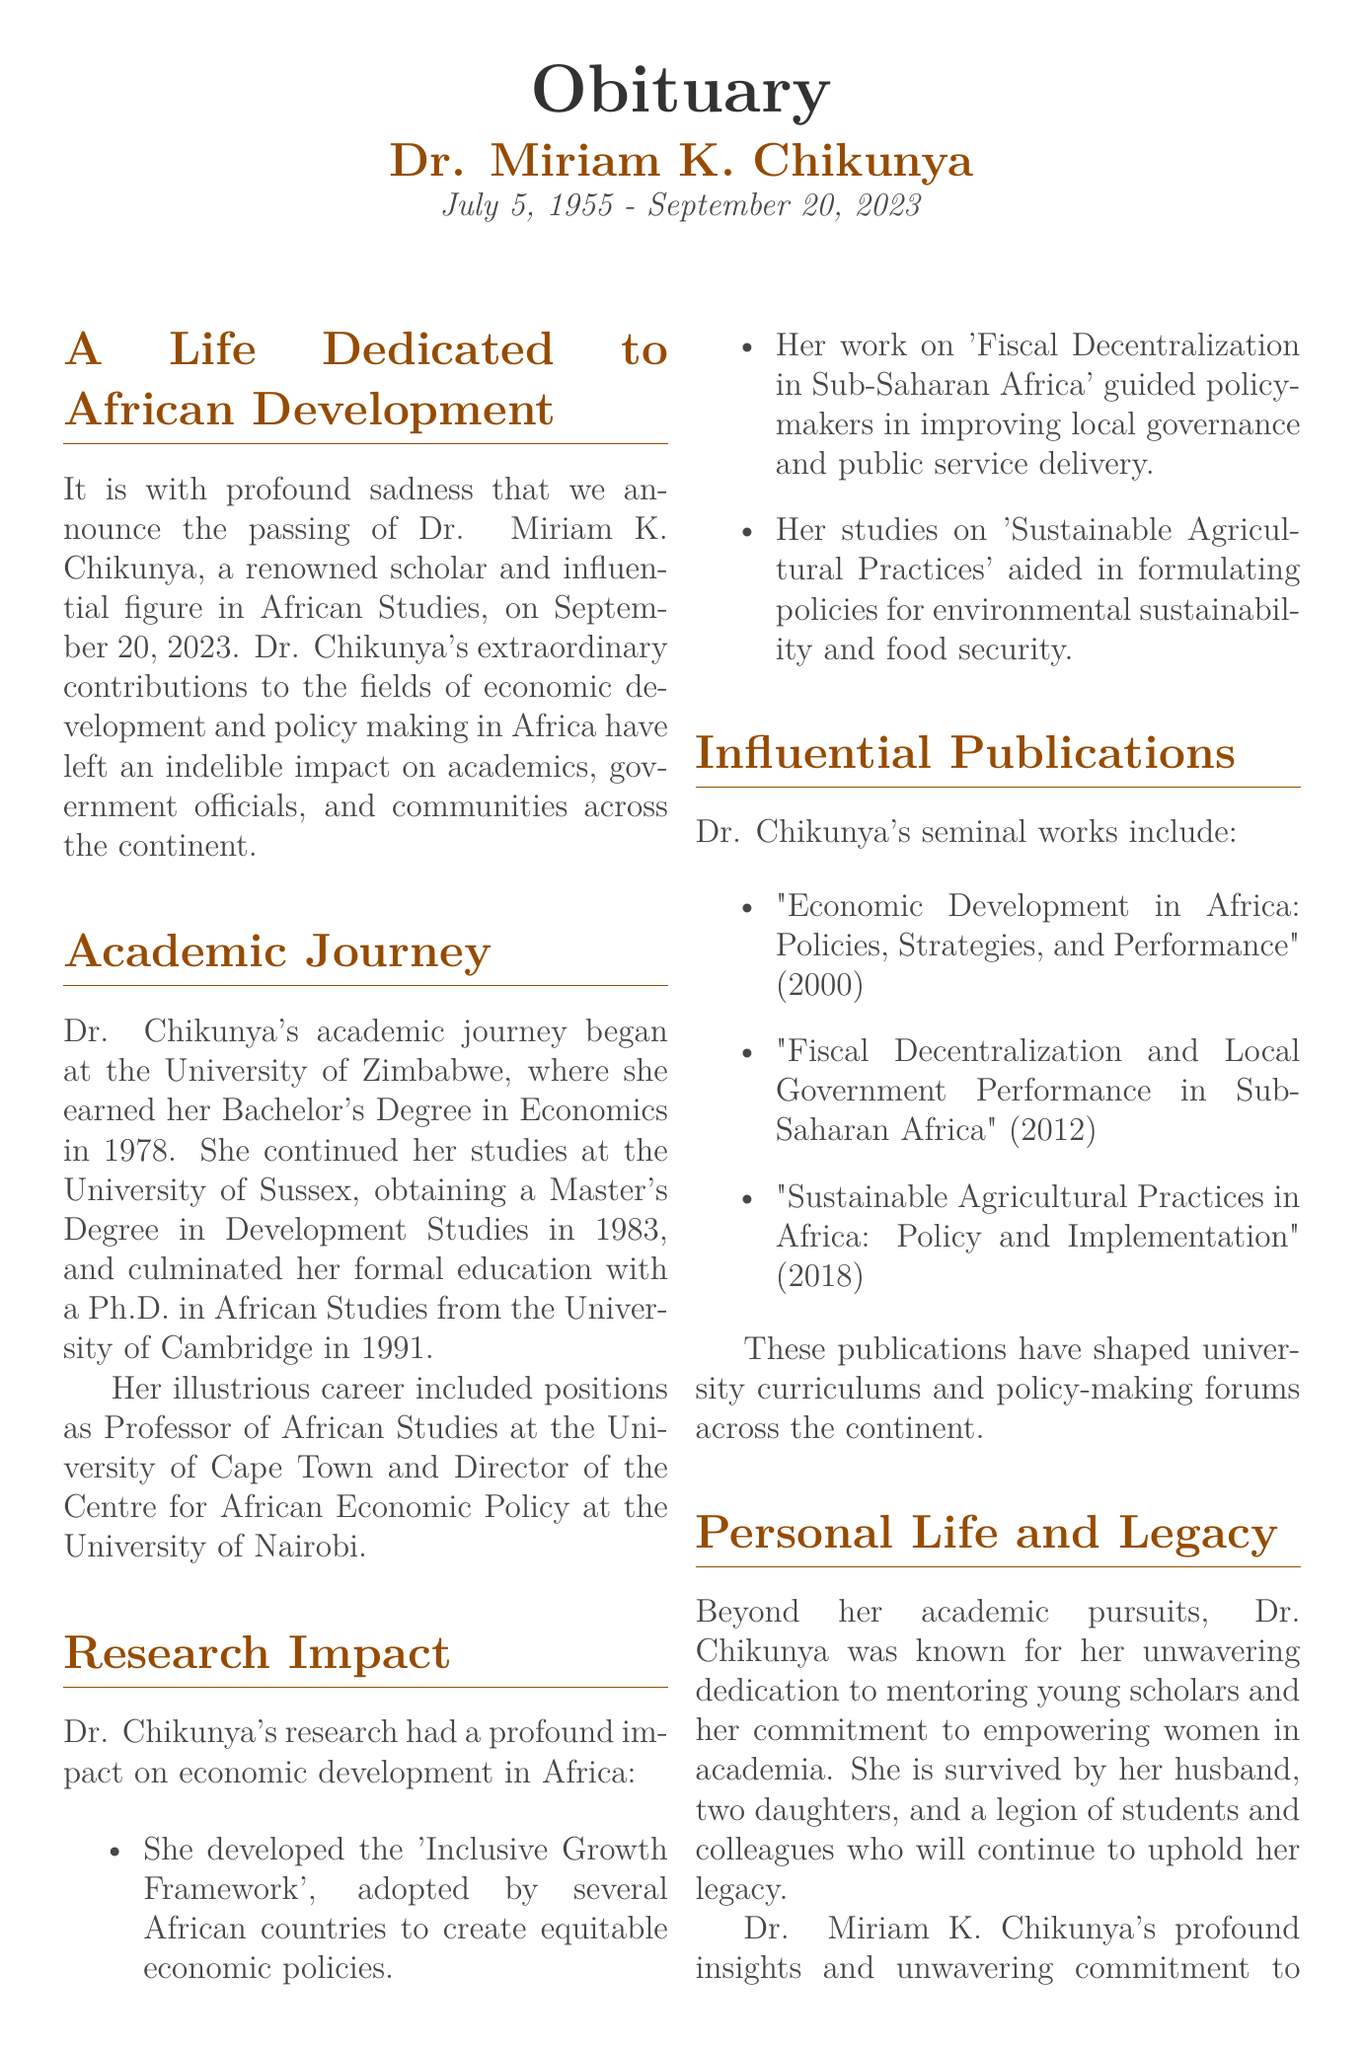What date did Dr. Miriam K. Chikunya pass away? The document states that Dr. Chikunya passed away on September 20, 2023.
Answer: September 20, 2023 What degree did Dr. Chikunya earn at the University of Zimbabwe? The document mentions that she earned her Bachelor's Degree in Economics at the University of Zimbabwe.
Answer: Bachelor's Degree in Economics Which framework developed by Dr. Chikunya was adopted by several African countries? The document describes the 'Inclusive Growth Framework' developed by her as being adopted by several African countries.
Answer: Inclusive Growth Framework How many daughters does Dr. Chikunya have? According to the document, Dr. Chikunya is survived by two daughters.
Answer: two What was the title of Dr. Chikunya's 2012 publication? The document lists "Fiscal Decentralization and Local Government Performance in Sub-Saharan Africa" as her publication from 2012.
Answer: Fiscal Decentralization and Local Government Performance in Sub-Saharan Africa What aspect of development did Dr. Chikunya focus on in her research? The document highlights her focus on economic development and policy making in Africa as a prominent aspect of her research.
Answer: Economic development and policy making What is a key component of Dr. Chikunya's legacy mentioned in the document? The document states that she was known for her commitment to mentoring young scholars, which is a key component of her legacy.
Answer: Mentoring young scholars Which university was Dr. Chikunya a professor at? The document mentions that Dr. Chikunya served as Professor of African Studies at the University of Cape Town.
Answer: University of Cape Town What year did Dr. Chikunya complete her Ph.D.? The document states that she completed her Ph.D. in 1991.
Answer: 1991 